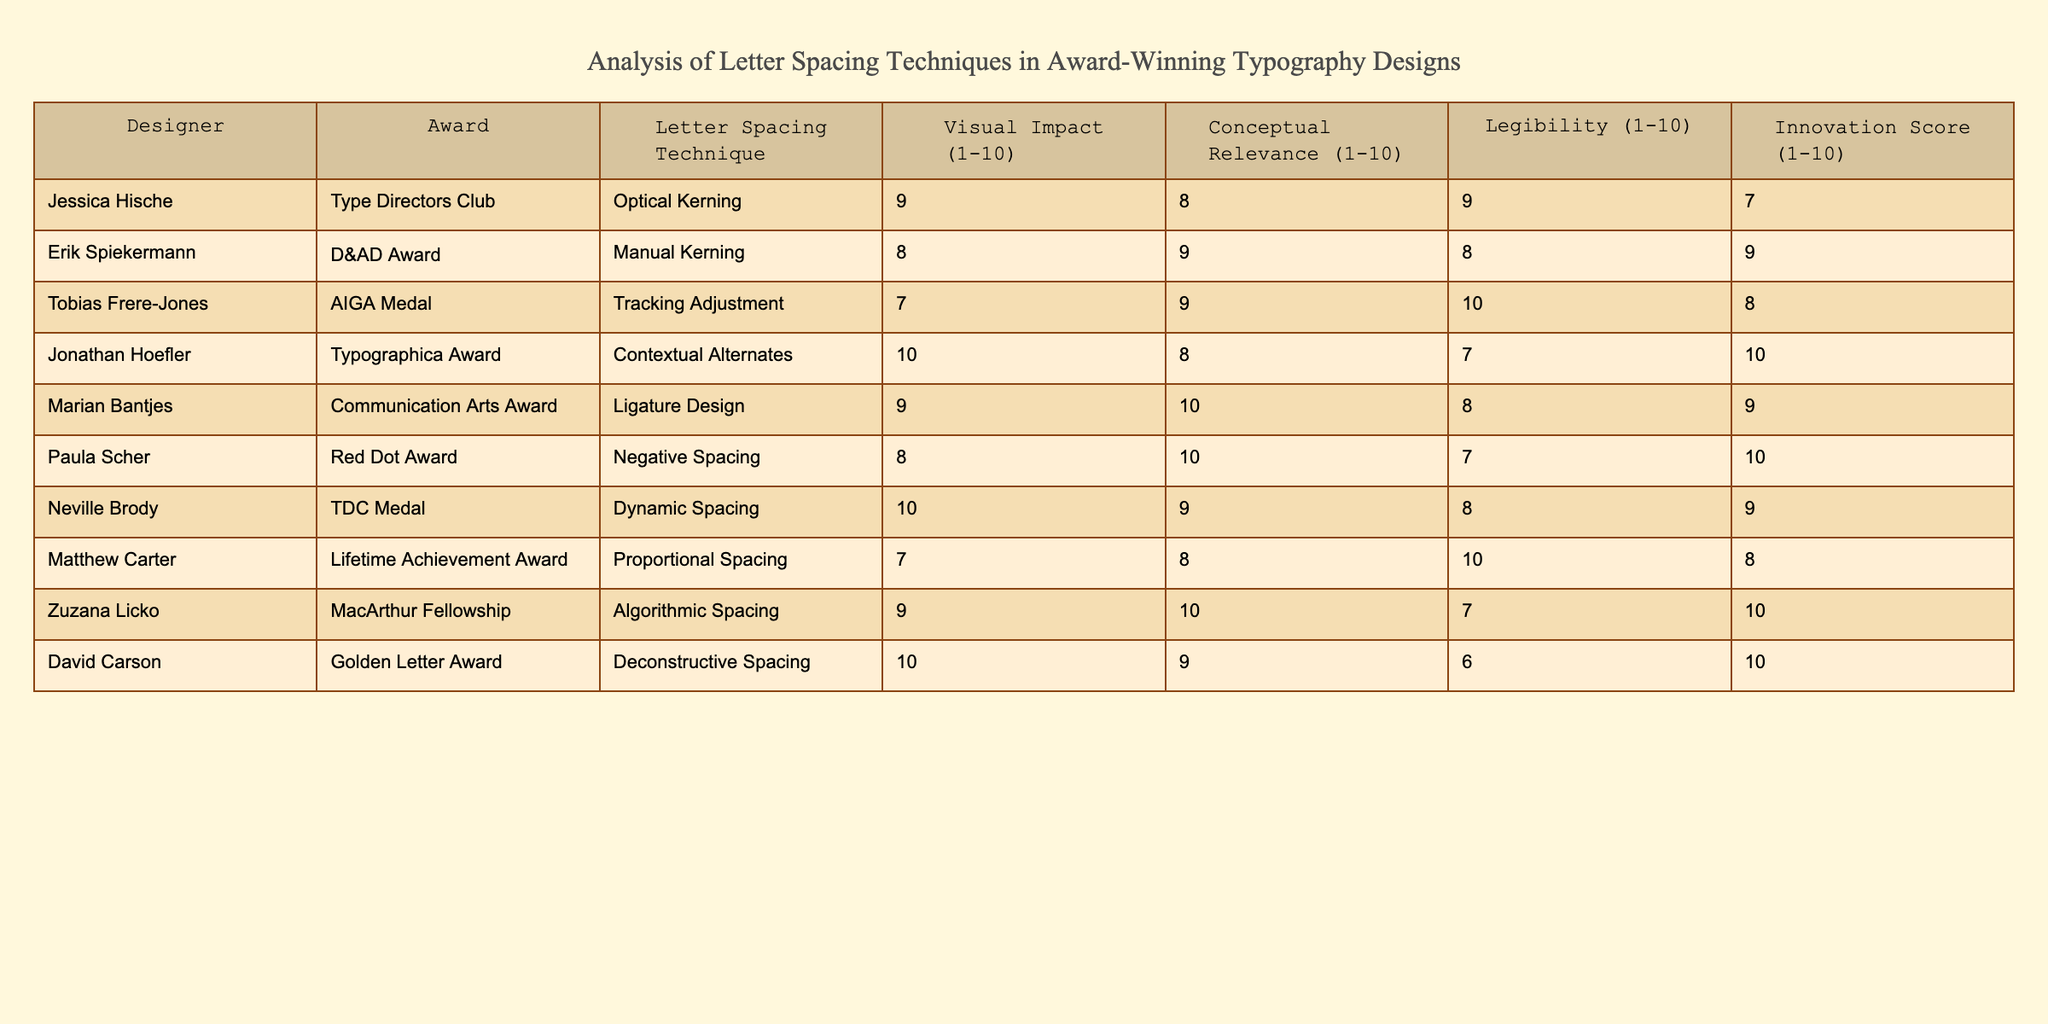What letter spacing technique did David Carson use? The table shows that David Carson used "Deconstructive Spacing" for his typography design.
Answer: Deconstructive Spacing Who received the highest score for visual impact? The highest score for visual impact in the table is 10, which was achieved by Jonathan Hoefler and David Carson.
Answer: Jonathan Hoefler and David Carson What is the average innovation score of the designers listed? The innovation scores are: 7, 9, 8, 10, 9, 10, 9, 8, 10, 10. Summing these scores gives 80, and dividing by the number of designers (10) results in an average of 8.
Answer: 8 Is there a designer who scored 9 in both visual impact and conceptual relevance? By inspecting the table, we can see that both Jessica Hische and Zuzana Licko scored 9 in visual impact, but only Zuzana Licko scored 10 in conceptual relevance. Therefore, no designer scored 9 in both categories.
Answer: No What is the difference between the highest and lowest legibility scores in the table? The highest legibility score is 10 (Tobias Frere-Jones and Matthew Carter) and the lowest is 6 (David Carson). The difference is 10 - 6 = 4.
Answer: 4 Which designer scored the highest in both conceptual relevance and innovation? Looking at the table, Marian Bantjes achieved the highest score of 10 for conceptual relevance and also 9 for innovation, but she is not the highest for innovation. Zuzana Licko and David Carson are tied with a score of 10 for innovation. Therefore, no single designer is highest in both areas.
Answer: No single designer is highest in both areas Which letter spacing technique has the highest average legibility score? The legibility scores for the techniques are: Optical Kerning (9), Manual Kerning (8), Tracking Adjustment (10), Contextual Alternates (7), Ligature Design (8), Negative Spacing (7), Dynamic Spacing (8), Proportional Spacing (10), Algorithmic Spacing (7), Deconstructive Spacing (6). The average is calculated by adding them and dividing by the number of techniques (10), yielding (9 + 8 + 10 + 7 + 8 + 7 + 8 + 10 + 7 + 6) / 10 = 8.
Answer: Tracking Adjustment How many techniques scored above 9 for both visual impact and innovation? By reviewing the table, we see that the techniques "Jonathan Hoefler" (10 visual impact, 10 innovation) and "David Carson" (10 visual impact, 10 innovation) both exceed a score of 9 in these categories. Thus, there are two techniques in total.
Answer: 2 Who has the lowest score in visual impact and what technique did they use? In the table, Matthew Carter has the lowest score in visual impact at 7, and the technique used is "Proportional Spacing."
Answer: Matthew Carter, Proportional Spacing 